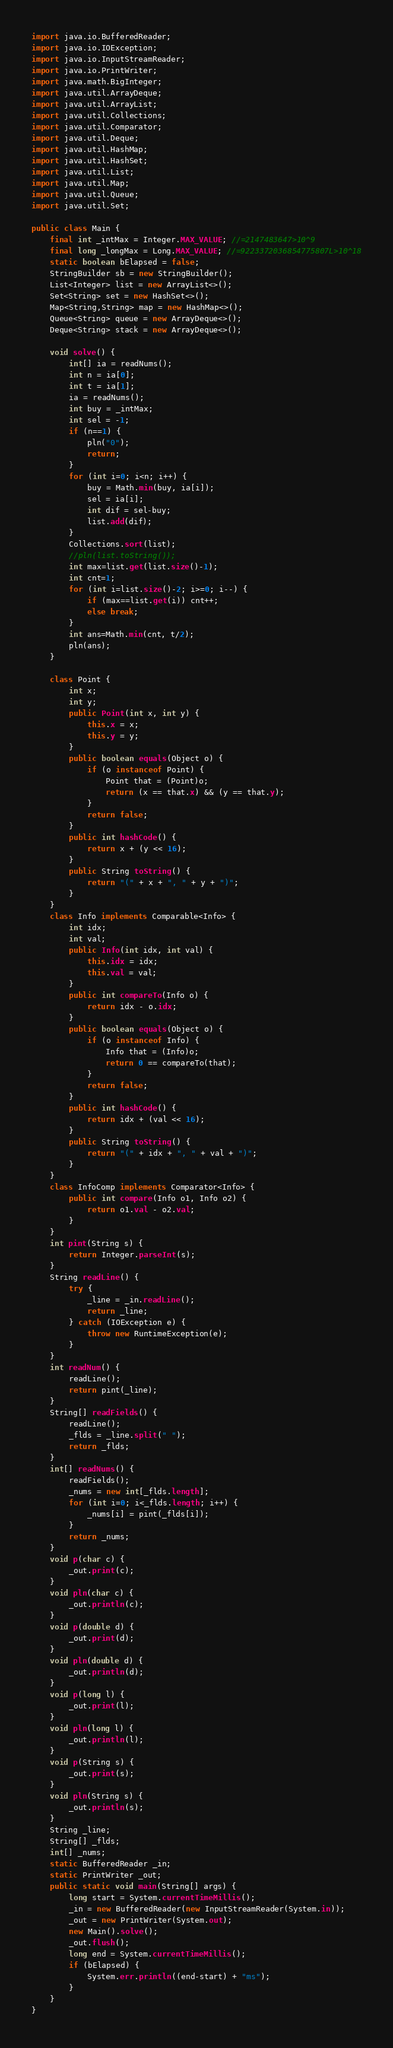Convert code to text. <code><loc_0><loc_0><loc_500><loc_500><_Java_>import java.io.BufferedReader;
import java.io.IOException;
import java.io.InputStreamReader;
import java.io.PrintWriter;
import java.math.BigInteger;
import java.util.ArrayDeque;
import java.util.ArrayList;
import java.util.Collections;
import java.util.Comparator;
import java.util.Deque;
import java.util.HashMap;
import java.util.HashSet;
import java.util.List;
import java.util.Map;
import java.util.Queue;
import java.util.Set;

public class Main {
	final int _intMax = Integer.MAX_VALUE; //=2147483647>10^9
	final long _longMax = Long.MAX_VALUE; //=9223372036854775807L>10^18
	static boolean bElapsed = false;
	StringBuilder sb = new StringBuilder();
	List<Integer> list = new ArrayList<>();
	Set<String> set = new HashSet<>();
	Map<String,String> map = new HashMap<>();
	Queue<String> queue = new ArrayDeque<>();
	Deque<String> stack = new ArrayDeque<>();

	void solve() {
		int[] ia = readNums();
		int n = ia[0];
		int t = ia[1];
		ia = readNums();
		int buy = _intMax;
		int sel = -1;
		if (n==1) {
			pln("0");
			return;
		}
		for (int i=0; i<n; i++) {
			buy = Math.min(buy, ia[i]);
			sel = ia[i];
			int dif = sel-buy;
			list.add(dif);
		}
		Collections.sort(list);
		//pln(list.toString());
		int max=list.get(list.size()-1);
		int cnt=1;
		for (int i=list.size()-2; i>=0; i--) {
			if (max==list.get(i)) cnt++;
			else break;
		}
		int ans=Math.min(cnt, t/2);
		pln(ans);
	}

	class Point {
		int x;
		int y;
		public Point(int x, int y) {
			this.x = x;
			this.y = y;
		}
		public boolean equals(Object o) {
			if (o instanceof Point) {
				Point that = (Point)o;
				return (x == that.x) && (y == that.y);
			}
			return false;
		}
		public int hashCode() {
			return x + (y << 16);
		}
		public String toString() {
			return "(" + x + ", " + y + ")";
		}
	}
	class Info implements Comparable<Info> {
		int idx;
		int val;
		public Info(int idx, int val) {
			this.idx = idx;
			this.val = val;
		}
		public int compareTo(Info o) {
			return idx - o.idx;
		}
		public boolean equals(Object o) {
			if (o instanceof Info) {
				Info that = (Info)o;
				return 0 == compareTo(that);
			}
			return false;
		}
		public int hashCode() {
			return idx + (val << 16);
		}
		public String toString() {
			return "(" + idx + ", " + val + ")";
		}
	}
	class InfoComp implements Comparator<Info> {
		public int compare(Info o1, Info o2) {
			return o1.val - o2.val;
		}
	}
	int pint(String s) {
		return Integer.parseInt(s);
	}
	String readLine() {
		try {
			_line = _in.readLine();
			return _line;
		} catch (IOException e) {
			throw new RuntimeException(e);
		}
	}
	int readNum() {
		readLine();
		return pint(_line);
	}
	String[] readFields() {
		readLine();
		_flds = _line.split(" ");
		return _flds;
	}
	int[] readNums() {
		readFields();
		_nums = new int[_flds.length];
		for (int i=0; i<_flds.length; i++) {
			_nums[i] = pint(_flds[i]);
		}
		return _nums;
	}
	void p(char c) {
		_out.print(c);
	}
	void pln(char c) {
		_out.println(c);
	}
	void p(double d) {
		_out.print(d);
	}
	void pln(double d) {
		_out.println(d);
	}
	void p(long l) {
		_out.print(l);
	}
	void pln(long l) {
		_out.println(l);
	}
	void p(String s) {
		_out.print(s);
	}
	void pln(String s) {
		_out.println(s);
	}
	String _line;
	String[] _flds;
	int[] _nums;
	static BufferedReader _in;
	static PrintWriter _out;
	public static void main(String[] args) {
		long start = System.currentTimeMillis();
		_in = new BufferedReader(new InputStreamReader(System.in));
		_out = new PrintWriter(System.out);
		new Main().solve();
		_out.flush();
		long end = System.currentTimeMillis();
		if (bElapsed) {
			System.err.println((end-start) + "ms");
		}
	}
}
</code> 